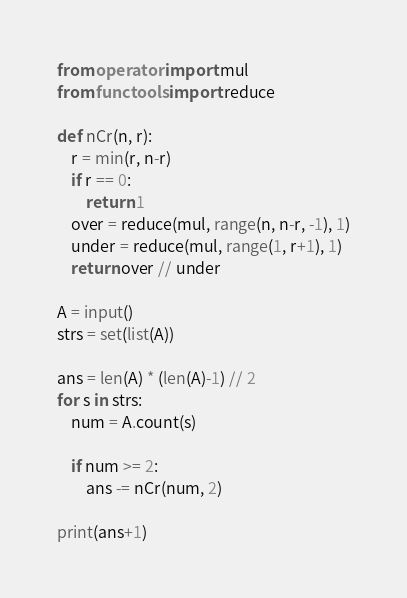<code> <loc_0><loc_0><loc_500><loc_500><_Python_>from operator import mul
from functools import reduce

def nCr(n, r):
    r = min(r, n-r)
    if r == 0:
        return 1
    over = reduce(mul, range(n, n-r, -1), 1)
    under = reduce(mul, range(1, r+1), 1)
    return over // under

A = input()
strs = set(list(A))

ans = len(A) * (len(A)-1) // 2
for s in strs:
    num = A.count(s)

    if num >= 2:
        ans -= nCr(num, 2)

print(ans+1)</code> 